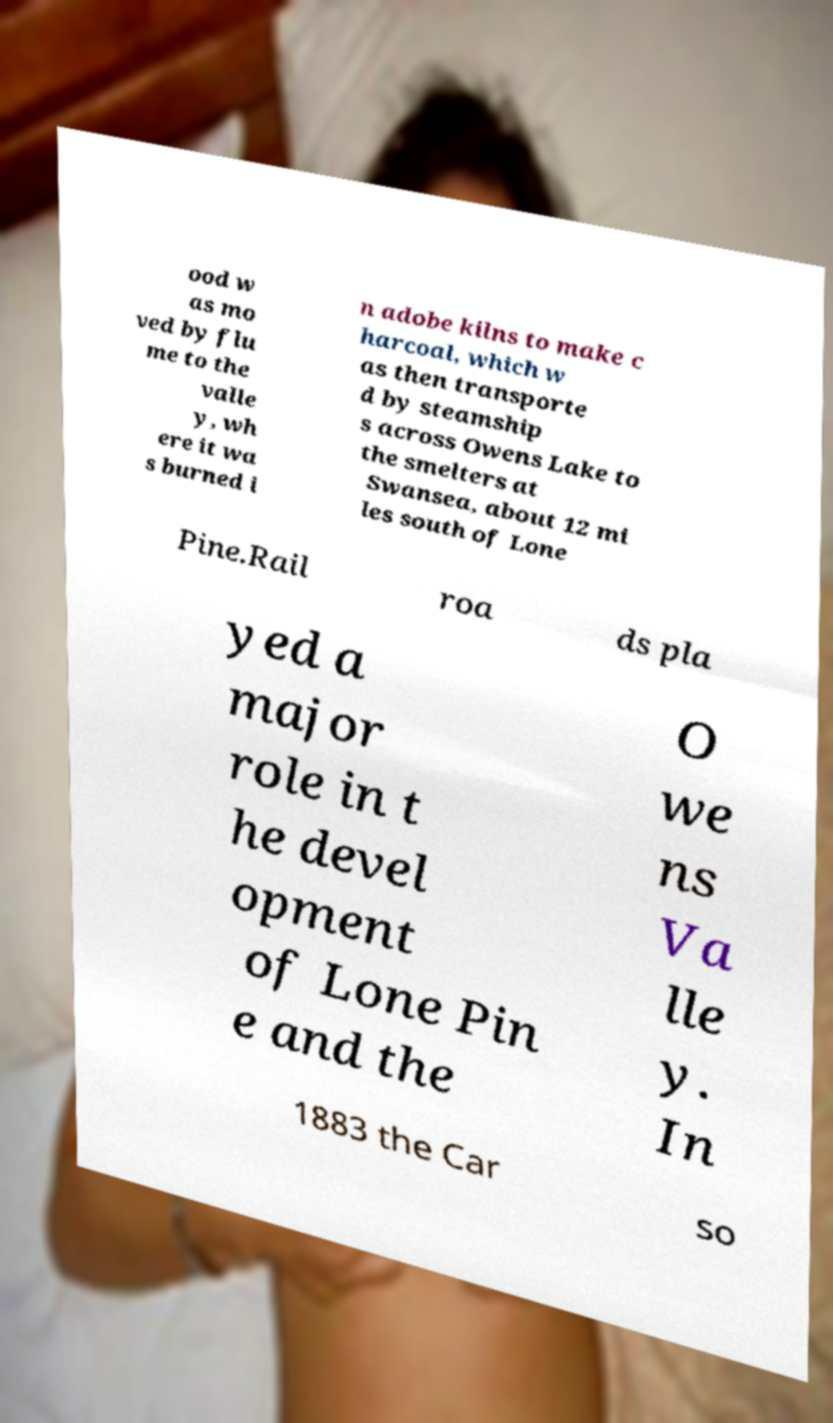Could you extract and type out the text from this image? ood w as mo ved by flu me to the valle y, wh ere it wa s burned i n adobe kilns to make c harcoal, which w as then transporte d by steamship s across Owens Lake to the smelters at Swansea, about 12 mi les south of Lone Pine.Rail roa ds pla yed a major role in t he devel opment of Lone Pin e and the O we ns Va lle y. In 1883 the Car so 